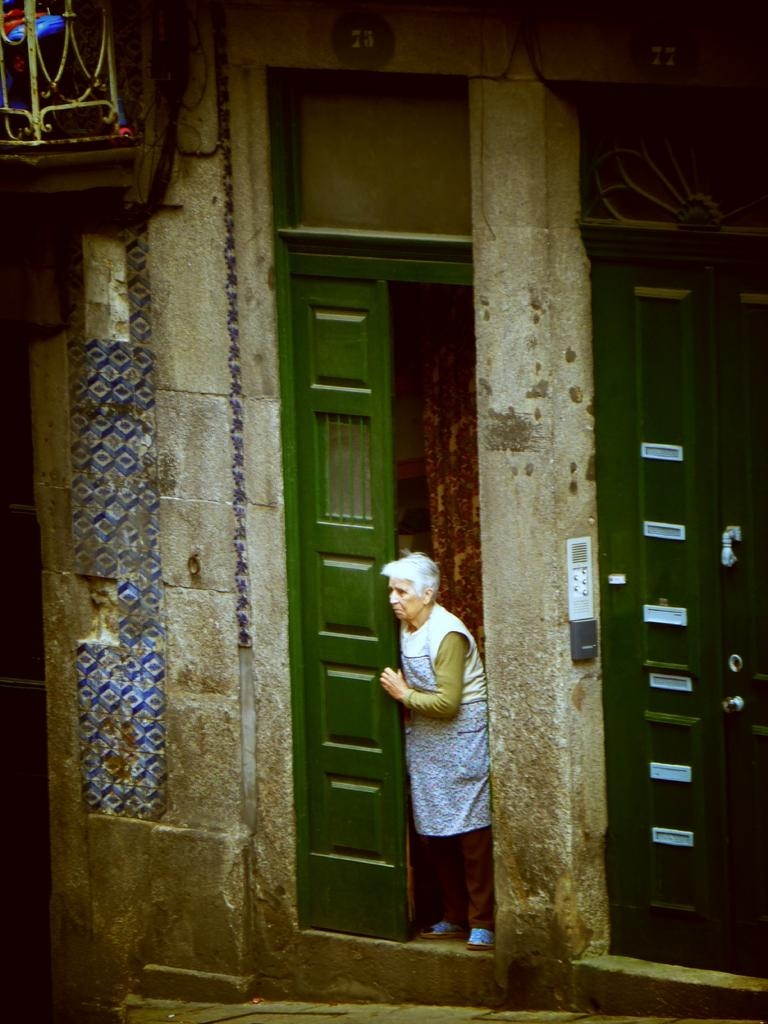How many green doors are visible in the image? There are two green doors in the image. What is the context of the doors in the image? The doors are part of a wall. Who is present in the image besides the doors? There is a woman standing beside the door. What direction is the woman looking in? The woman is looking to the left. What can be seen in the top left corner of the image? There is a wooden object in the top left corner of the image. How many cacti are visible in the image? There are no cacti present in the image. What type of lumber is being used to construct the doors in the image? The provided facts do not mention the material used for the doors, so it cannot be determined from the image. 